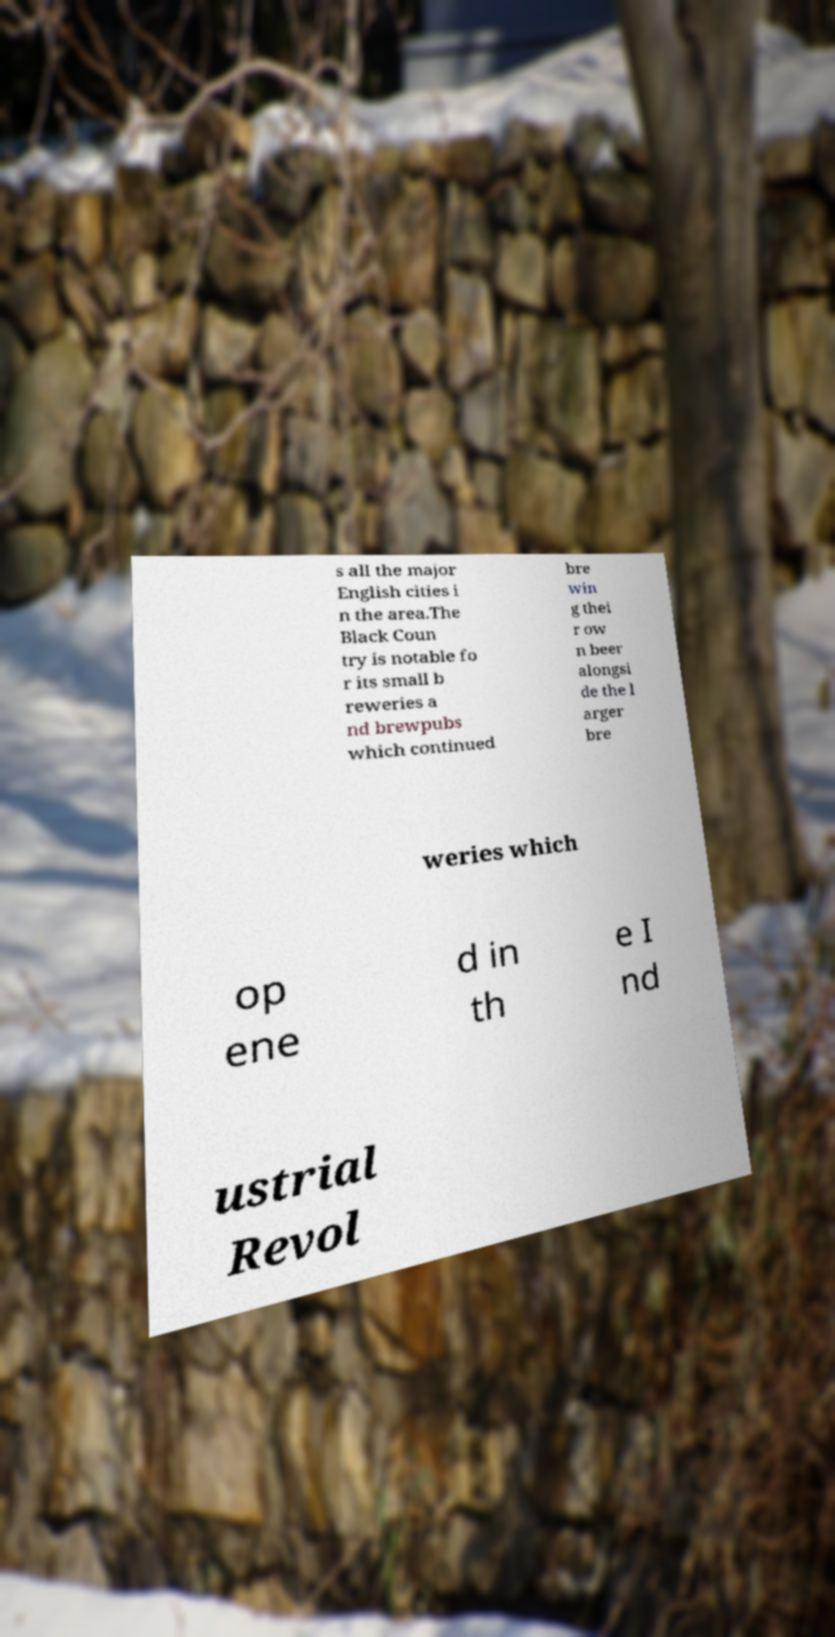I need the written content from this picture converted into text. Can you do that? s all the major English cities i n the area.The Black Coun try is notable fo r its small b reweries a nd brewpubs which continued bre win g thei r ow n beer alongsi de the l arger bre weries which op ene d in th e I nd ustrial Revol 